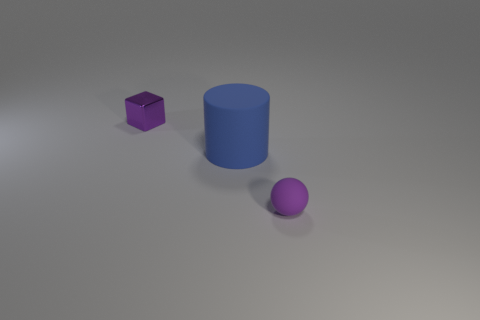Add 2 small yellow balls. How many objects exist? 5 Subtract all spheres. How many objects are left? 2 Add 3 tiny blue metal balls. How many tiny blue metal balls exist? 3 Subtract 0 blue spheres. How many objects are left? 3 Subtract all small metal objects. Subtract all big cylinders. How many objects are left? 1 Add 2 rubber cylinders. How many rubber cylinders are left? 3 